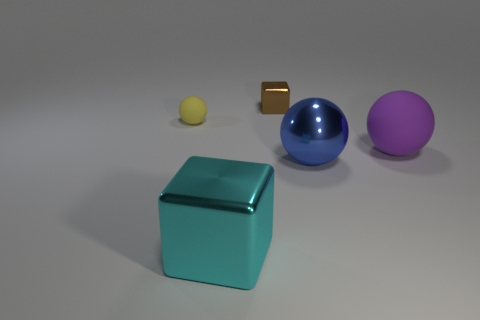Subtract all matte balls. How many balls are left? 1 Add 2 green metallic cubes. How many objects exist? 7 Subtract 1 blocks. How many blocks are left? 1 Add 5 big yellow cubes. How many big yellow cubes exist? 5 Subtract all yellow balls. How many balls are left? 2 Subtract 0 purple blocks. How many objects are left? 5 Subtract all cubes. How many objects are left? 3 Subtract all red cubes. Subtract all cyan balls. How many cubes are left? 2 Subtract all gray cylinders. How many yellow cubes are left? 0 Subtract all brown rubber things. Subtract all big metal blocks. How many objects are left? 4 